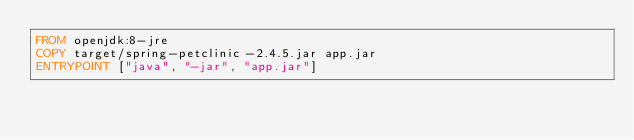<code> <loc_0><loc_0><loc_500><loc_500><_Dockerfile_>FROM openjdk:8-jre
COPY target/spring-petclinic-2.4.5.jar app.jar
ENTRYPOINT ["java", "-jar", "app.jar"]
</code> 